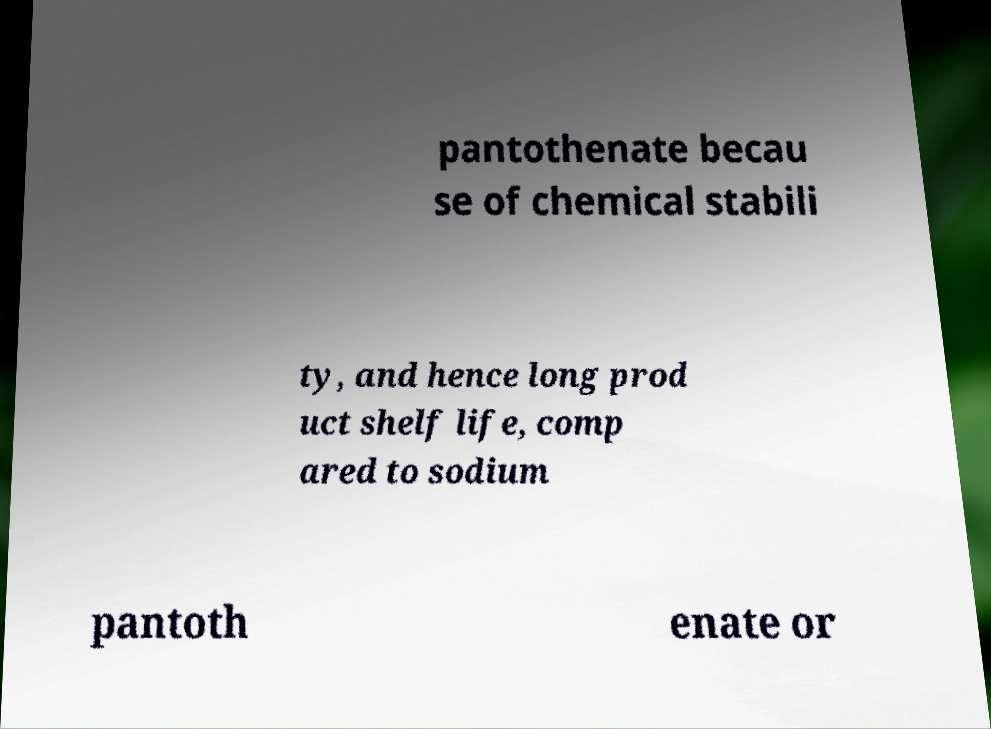Could you assist in decoding the text presented in this image and type it out clearly? pantothenate becau se of chemical stabili ty, and hence long prod uct shelf life, comp ared to sodium pantoth enate or 